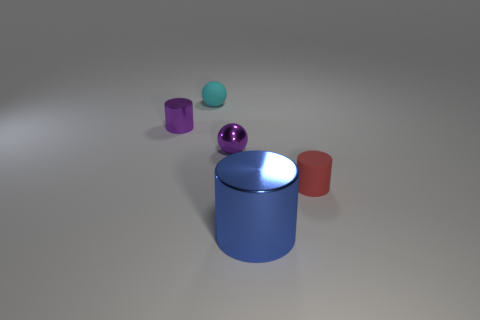Is there any other thing that is the same size as the blue thing?
Give a very brief answer. No. What size is the red object that is made of the same material as the cyan ball?
Keep it short and to the point. Small. Is the material of the cylinder that is to the right of the large shiny cylinder the same as the purple sphere?
Keep it short and to the point. No. The ball that is made of the same material as the tiny purple cylinder is what color?
Make the answer very short. Purple. There is a small cylinder that is to the left of the purple metal ball; is its color the same as the ball that is right of the small cyan object?
Offer a terse response. Yes. How many balls are either rubber things or red rubber objects?
Offer a terse response. 1. Are there an equal number of metal things that are behind the tiny cyan matte sphere and big purple rubber cylinders?
Give a very brief answer. Yes. There is a tiny cyan sphere that is behind the purple shiny object that is in front of the purple object that is left of the metallic ball; what is its material?
Your answer should be compact. Rubber. How many things are cylinders that are to the left of the big cylinder or purple balls?
Make the answer very short. 2. How many things are either brown cubes or cylinders on the right side of the blue shiny object?
Provide a short and direct response. 1. 